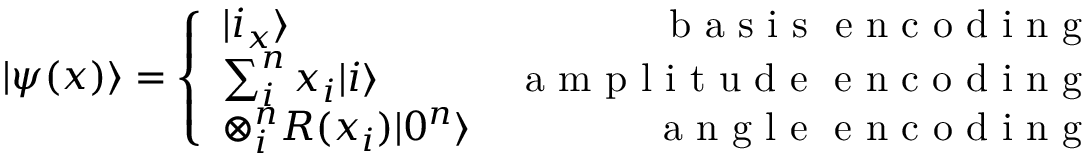Convert formula to latex. <formula><loc_0><loc_0><loc_500><loc_500>| \psi ( x ) \rangle = \left \{ \begin{array} { l r } { | i _ { x } \rangle } & { b a s i s \ e n c o d i n g } \\ { \sum _ { i } ^ { n } x _ { i } | i \rangle } & { a m p l i t u d e \ e n c o d i n g } \\ { \otimes _ { i } ^ { n } R ( x _ { i } ) | 0 ^ { n } \rangle } & { a n g l e \ e n c o d i n g } \end{array}</formula> 